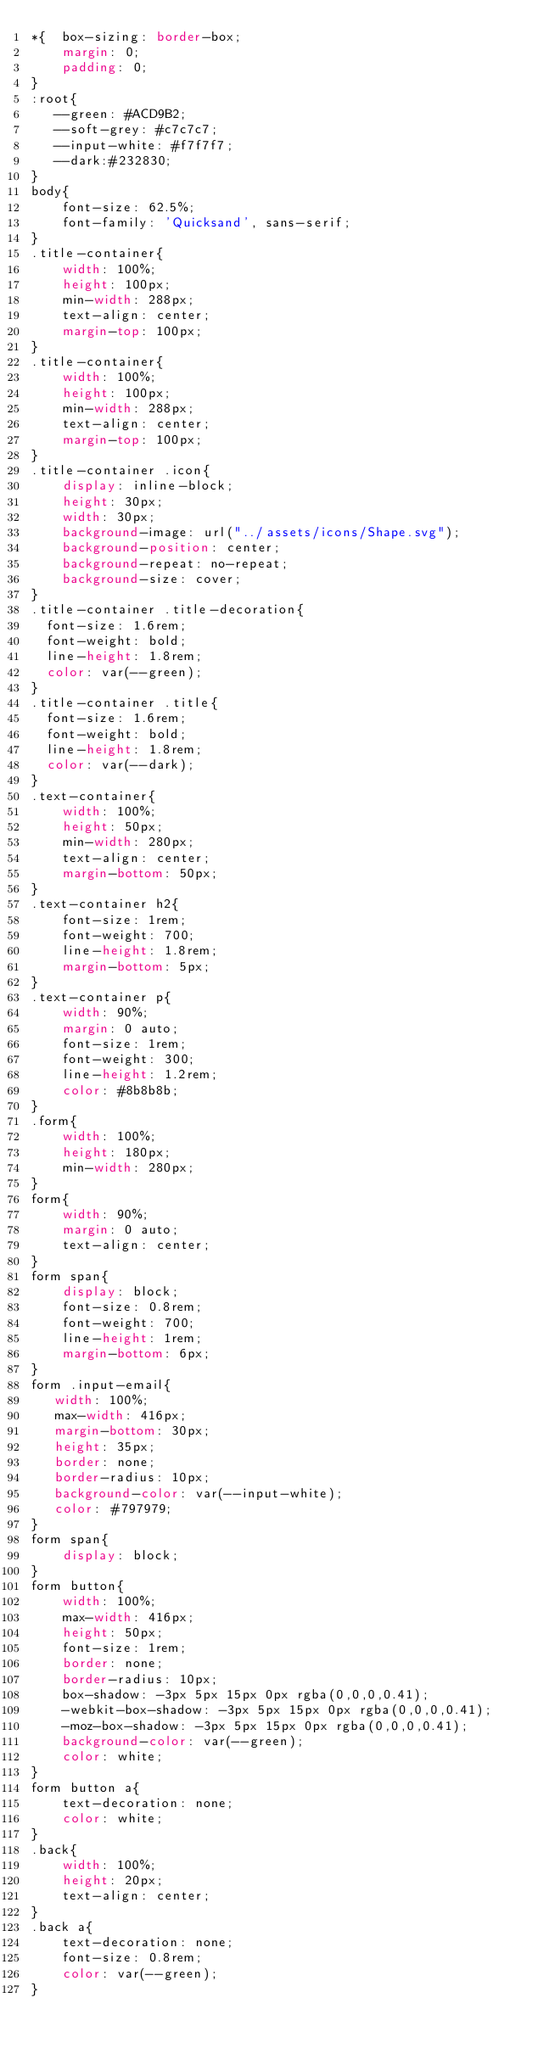Convert code to text. <code><loc_0><loc_0><loc_500><loc_500><_CSS_>*{  box-sizing: border-box;
    margin: 0; 
    padding: 0;
}
:root{
   --green: #ACD9B2;
   --soft-grey: #c7c7c7;
   --input-white: #f7f7f7;
   --dark:#232830;
}
body{
    font-size: 62.5%;
    font-family: 'Quicksand', sans-serif;
}
.title-container{
    width: 100%;
    height: 100px;
    min-width: 288px;
    text-align: center;
    margin-top: 100px;
}
.title-container{
    width: 100%;
    height: 100px;
    min-width: 288px;
    text-align: center;
    margin-top: 100px;
}
.title-container .icon{
    display: inline-block;
    height: 30px;
    width: 30px;
    background-image: url("../assets/icons/Shape.svg");
    background-position: center;
    background-repeat: no-repeat;
    background-size: cover;
}
.title-container .title-decoration{
  font-size: 1.6rem;
  font-weight: bold;
  line-height: 1.8rem;
  color: var(--green);
}
.title-container .title{
  font-size: 1.6rem;
  font-weight: bold;
  line-height: 1.8rem;
  color: var(--dark);
}
.text-container{
    width: 100%;
    height: 50px;
    min-width: 280px;
    text-align: center;
    margin-bottom: 50px;
}
.text-container h2{
    font-size: 1rem;
    font-weight: 700;
    line-height: 1.8rem;
    margin-bottom: 5px;
}
.text-container p{
    width: 90%;
    margin: 0 auto;
    font-size: 1rem;
    font-weight: 300;
    line-height: 1.2rem;
    color: #8b8b8b;
}
.form{
    width: 100%;
    height: 180px;
    min-width: 280px;
}
form{
    width: 90%;
    margin: 0 auto;
    text-align: center;
}
form span{
    display: block;
    font-size: 0.8rem;
    font-weight: 700;
    line-height: 1rem;
    margin-bottom: 6px;
}
form .input-email{
   width: 100%;
   max-width: 416px;
   margin-bottom: 30px;
   height: 35px;
   border: none;
   border-radius: 10px;
   background-color: var(--input-white);
   color: #797979;
}
form span{
    display: block;
}
form button{
    width: 100%;
    max-width: 416px;
    height: 50px;
    font-size: 1rem;
    border: none;
    border-radius: 10px;
    box-shadow: -3px 5px 15px 0px rgba(0,0,0,0.41);
    -webkit-box-shadow: -3px 5px 15px 0px rgba(0,0,0,0.41);
    -moz-box-shadow: -3px 5px 15px 0px rgba(0,0,0,0.41);
    background-color: var(--green);
    color: white;
}
form button a{
    text-decoration: none;
    color: white;
}
.back{
    width: 100%;
    height: 20px;
    text-align: center;
}
.back a{
    text-decoration: none;
    font-size: 0.8rem;
    color: var(--green);
}</code> 